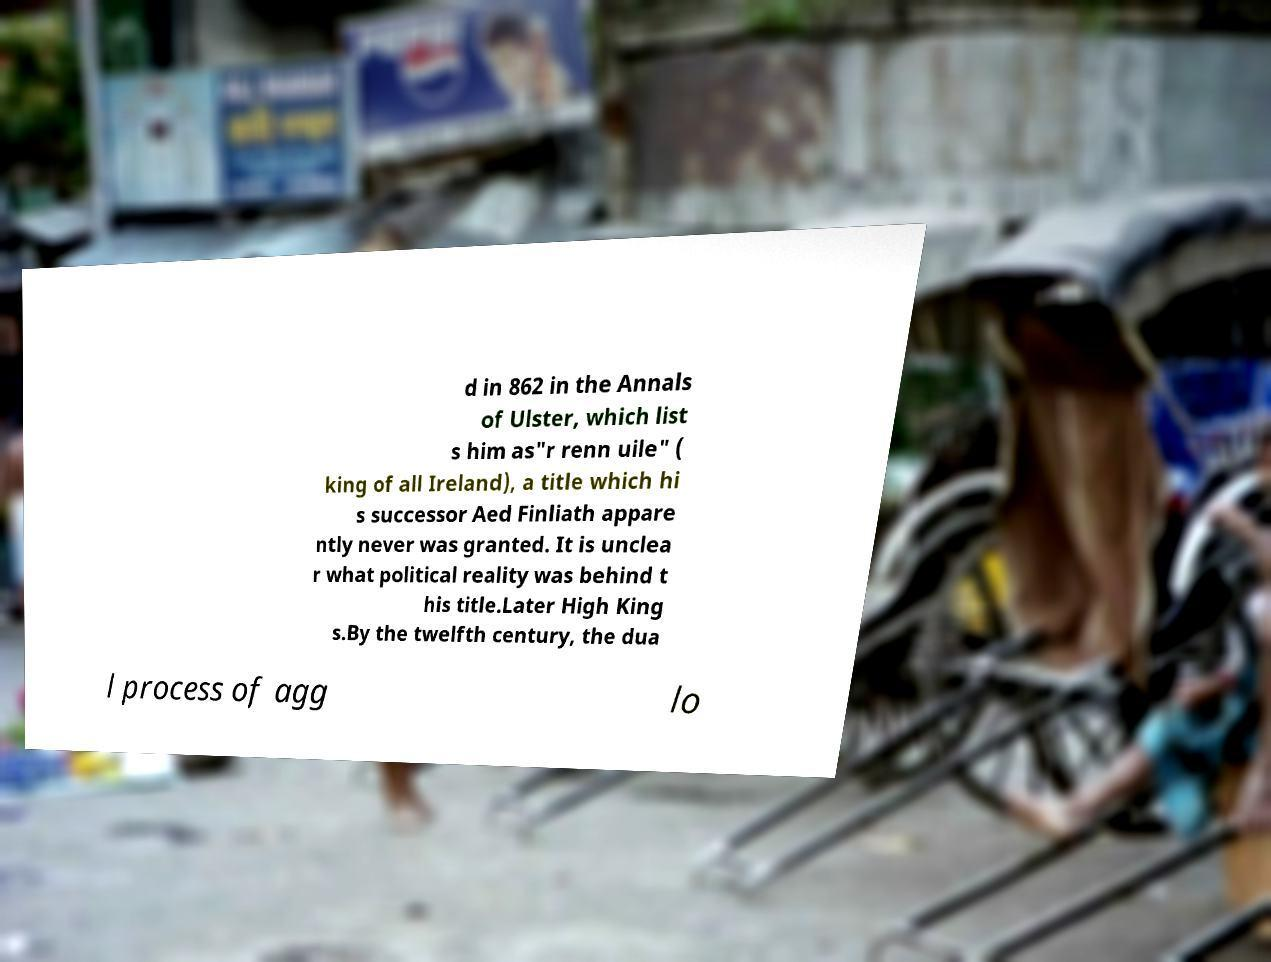Could you extract and type out the text from this image? d in 862 in the Annals of Ulster, which list s him as"r renn uile" ( king of all Ireland), a title which hi s successor Aed Finliath appare ntly never was granted. It is unclea r what political reality was behind t his title.Later High King s.By the twelfth century, the dua l process of agg lo 